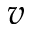Convert formula to latex. <formula><loc_0><loc_0><loc_500><loc_500>v</formula> 